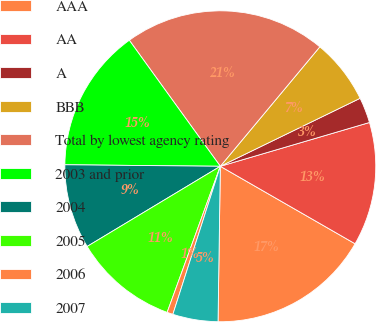Convert chart. <chart><loc_0><loc_0><loc_500><loc_500><pie_chart><fcel>AAA<fcel>AA<fcel>A<fcel>BBB<fcel>Total by lowest agency rating<fcel>2003 and prior<fcel>2004<fcel>2005<fcel>2006<fcel>2007<nl><fcel>16.93%<fcel>12.85%<fcel>2.66%<fcel>6.74%<fcel>21.01%<fcel>14.89%<fcel>8.78%<fcel>10.82%<fcel>0.62%<fcel>4.7%<nl></chart> 